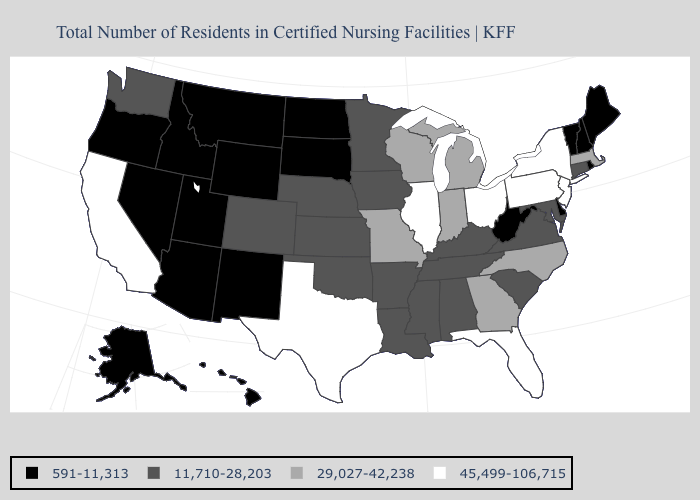Which states hav the highest value in the MidWest?
Quick response, please. Illinois, Ohio. Does the first symbol in the legend represent the smallest category?
Quick response, please. Yes. Which states have the lowest value in the South?
Be succinct. Delaware, West Virginia. What is the value of Tennessee?
Answer briefly. 11,710-28,203. Among the states that border Virginia , does West Virginia have the highest value?
Keep it brief. No. Does Colorado have a higher value than West Virginia?
Answer briefly. Yes. Name the states that have a value in the range 29,027-42,238?
Concise answer only. Georgia, Indiana, Massachusetts, Michigan, Missouri, North Carolina, Wisconsin. Name the states that have a value in the range 11,710-28,203?
Concise answer only. Alabama, Arkansas, Colorado, Connecticut, Iowa, Kansas, Kentucky, Louisiana, Maryland, Minnesota, Mississippi, Nebraska, Oklahoma, South Carolina, Tennessee, Virginia, Washington. Name the states that have a value in the range 591-11,313?
Give a very brief answer. Alaska, Arizona, Delaware, Hawaii, Idaho, Maine, Montana, Nevada, New Hampshire, New Mexico, North Dakota, Oregon, Rhode Island, South Dakota, Utah, Vermont, West Virginia, Wyoming. What is the value of Tennessee?
Short answer required. 11,710-28,203. What is the value of Washington?
Write a very short answer. 11,710-28,203. Name the states that have a value in the range 591-11,313?
Be succinct. Alaska, Arizona, Delaware, Hawaii, Idaho, Maine, Montana, Nevada, New Hampshire, New Mexico, North Dakota, Oregon, Rhode Island, South Dakota, Utah, Vermont, West Virginia, Wyoming. What is the value of Tennessee?
Quick response, please. 11,710-28,203. Is the legend a continuous bar?
Be succinct. No. Does Maryland have the same value as Pennsylvania?
Write a very short answer. No. 